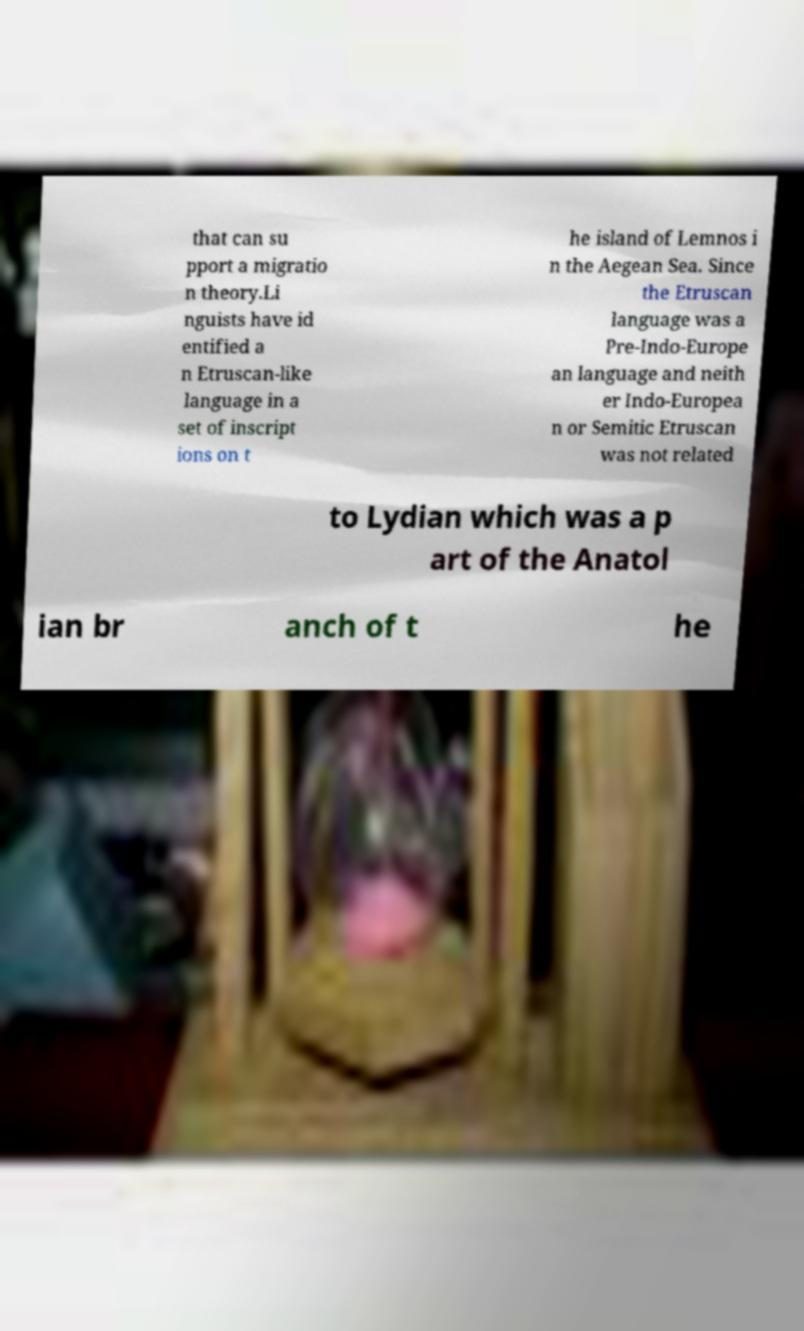Please identify and transcribe the text found in this image. that can su pport a migratio n theory.Li nguists have id entified a n Etruscan-like language in a set of inscript ions on t he island of Lemnos i n the Aegean Sea. Since the Etruscan language was a Pre-Indo-Europe an language and neith er Indo-Europea n or Semitic Etruscan was not related to Lydian which was a p art of the Anatol ian br anch of t he 